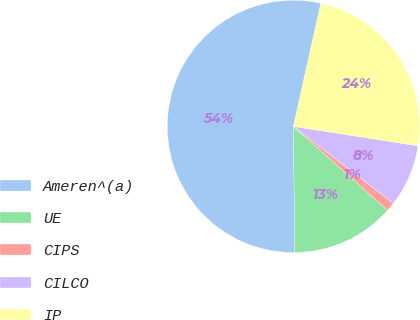<chart> <loc_0><loc_0><loc_500><loc_500><pie_chart><fcel>Ameren^(a)<fcel>UE<fcel>CIPS<fcel>CILCO<fcel>IP<nl><fcel>53.65%<fcel>13.24%<fcel>1.14%<fcel>7.99%<fcel>23.97%<nl></chart> 